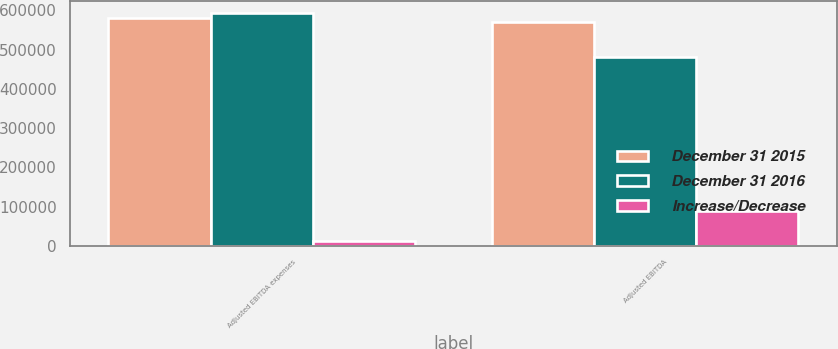Convert chart. <chart><loc_0><loc_0><loc_500><loc_500><stacked_bar_chart><ecel><fcel>Adjusted EBITDA expenses<fcel>Adjusted EBITDA<nl><fcel>December 31 2015<fcel>581212<fcel>569457<nl><fcel>December 31 2016<fcel>593316<fcel>481697<nl><fcel>Increase/Decrease<fcel>12104<fcel>87760<nl></chart> 